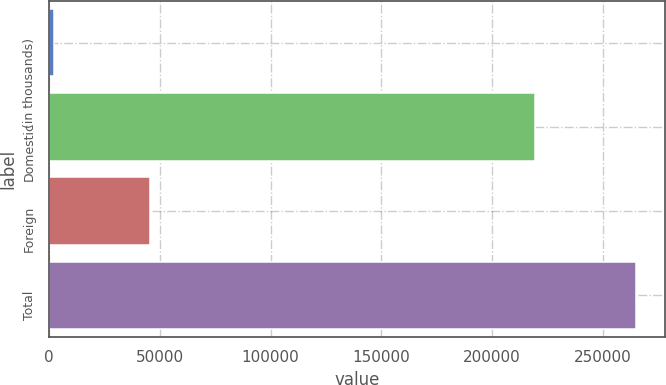Convert chart to OTSL. <chart><loc_0><loc_0><loc_500><loc_500><bar_chart><fcel>(in thousands)<fcel>Domestic<fcel>Foreign<fcel>Total<nl><fcel>2007<fcel>219265<fcel>45666<fcel>264931<nl></chart> 